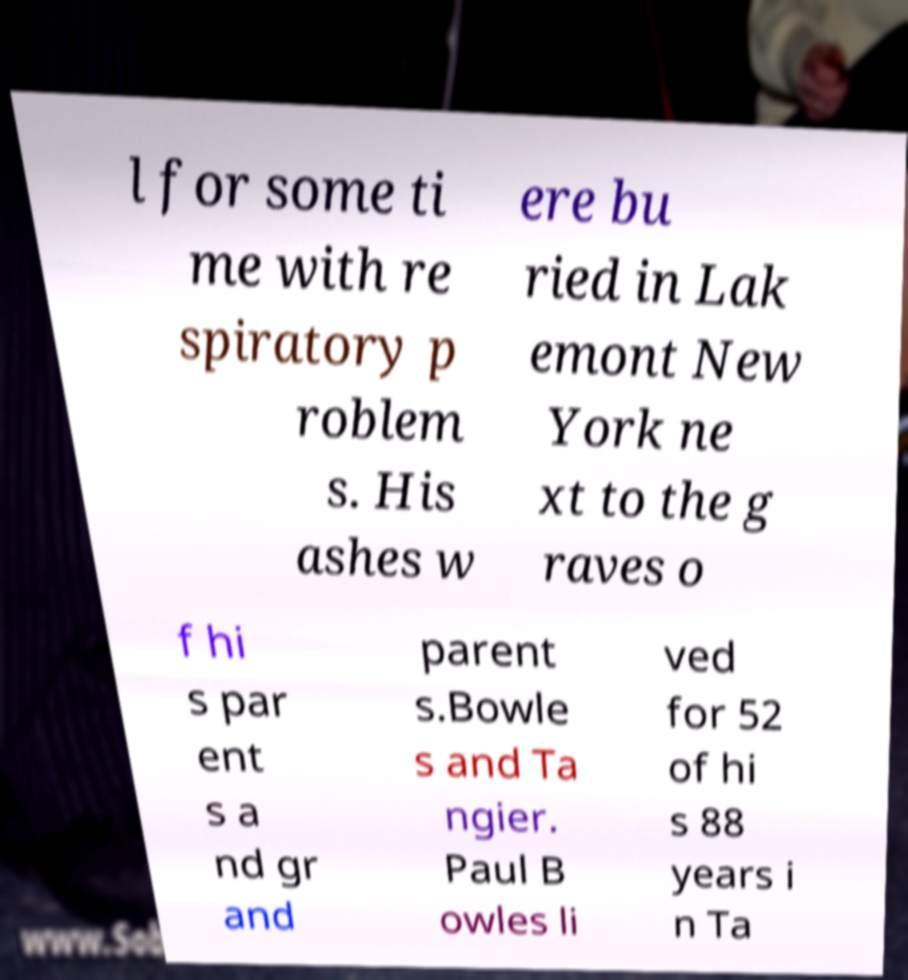Please read and relay the text visible in this image. What does it say? l for some ti me with re spiratory p roblem s. His ashes w ere bu ried in Lak emont New York ne xt to the g raves o f hi s par ent s a nd gr and parent s.Bowle s and Ta ngier. Paul B owles li ved for 52 of hi s 88 years i n Ta 